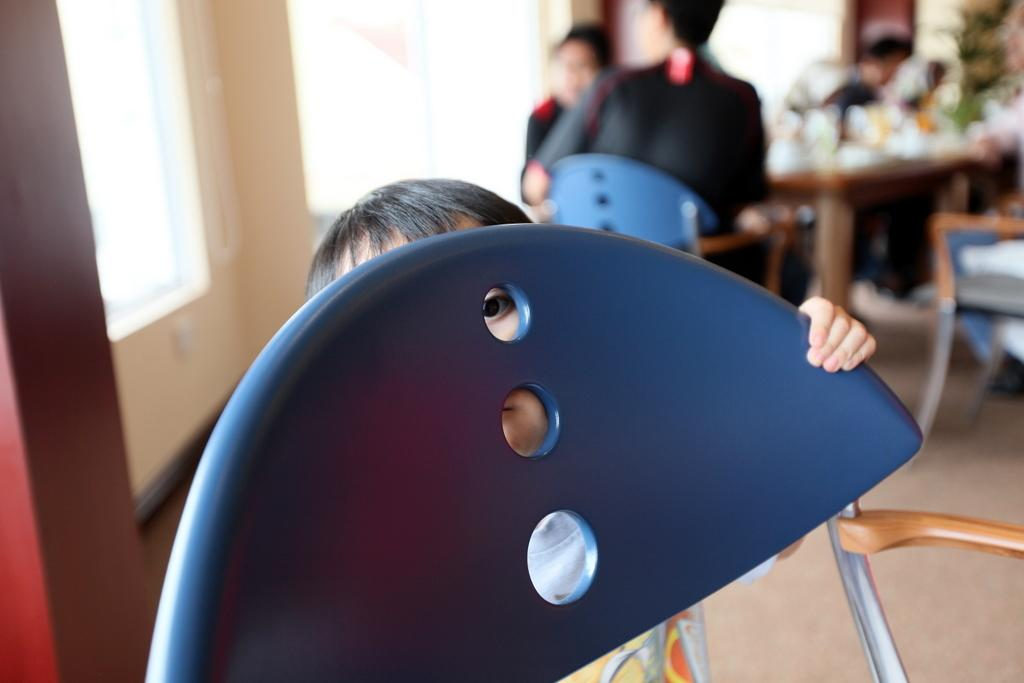What is the small child doing in the image? The small child is hiding behind a chair. What can be seen in the background of the image? There are two persons, a table, a chair, a wall, and windows in the background. How many people are visible in the image? There is one small child hiding behind a chair and two persons in the background, making a total of three people. What type of stomach pain is the small child experiencing in the image? There is no indication of any stomach pain in the image; the small child is simply hiding behind a chair. 